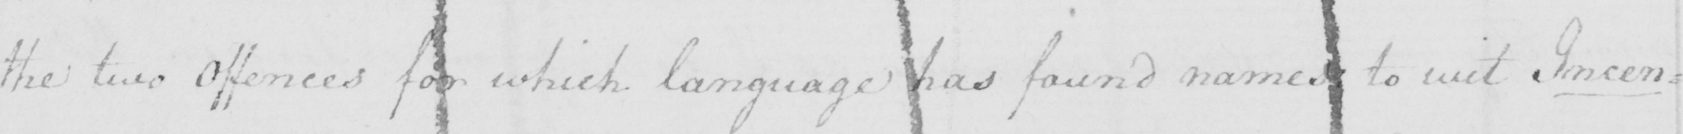Can you tell me what this handwritten text says? the two Offences for which language has found names to wit Incen= 